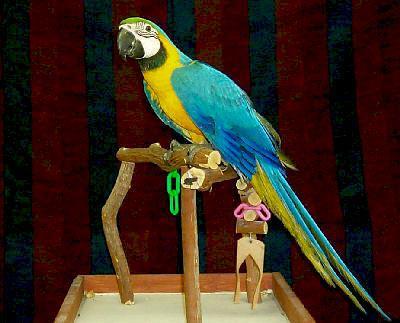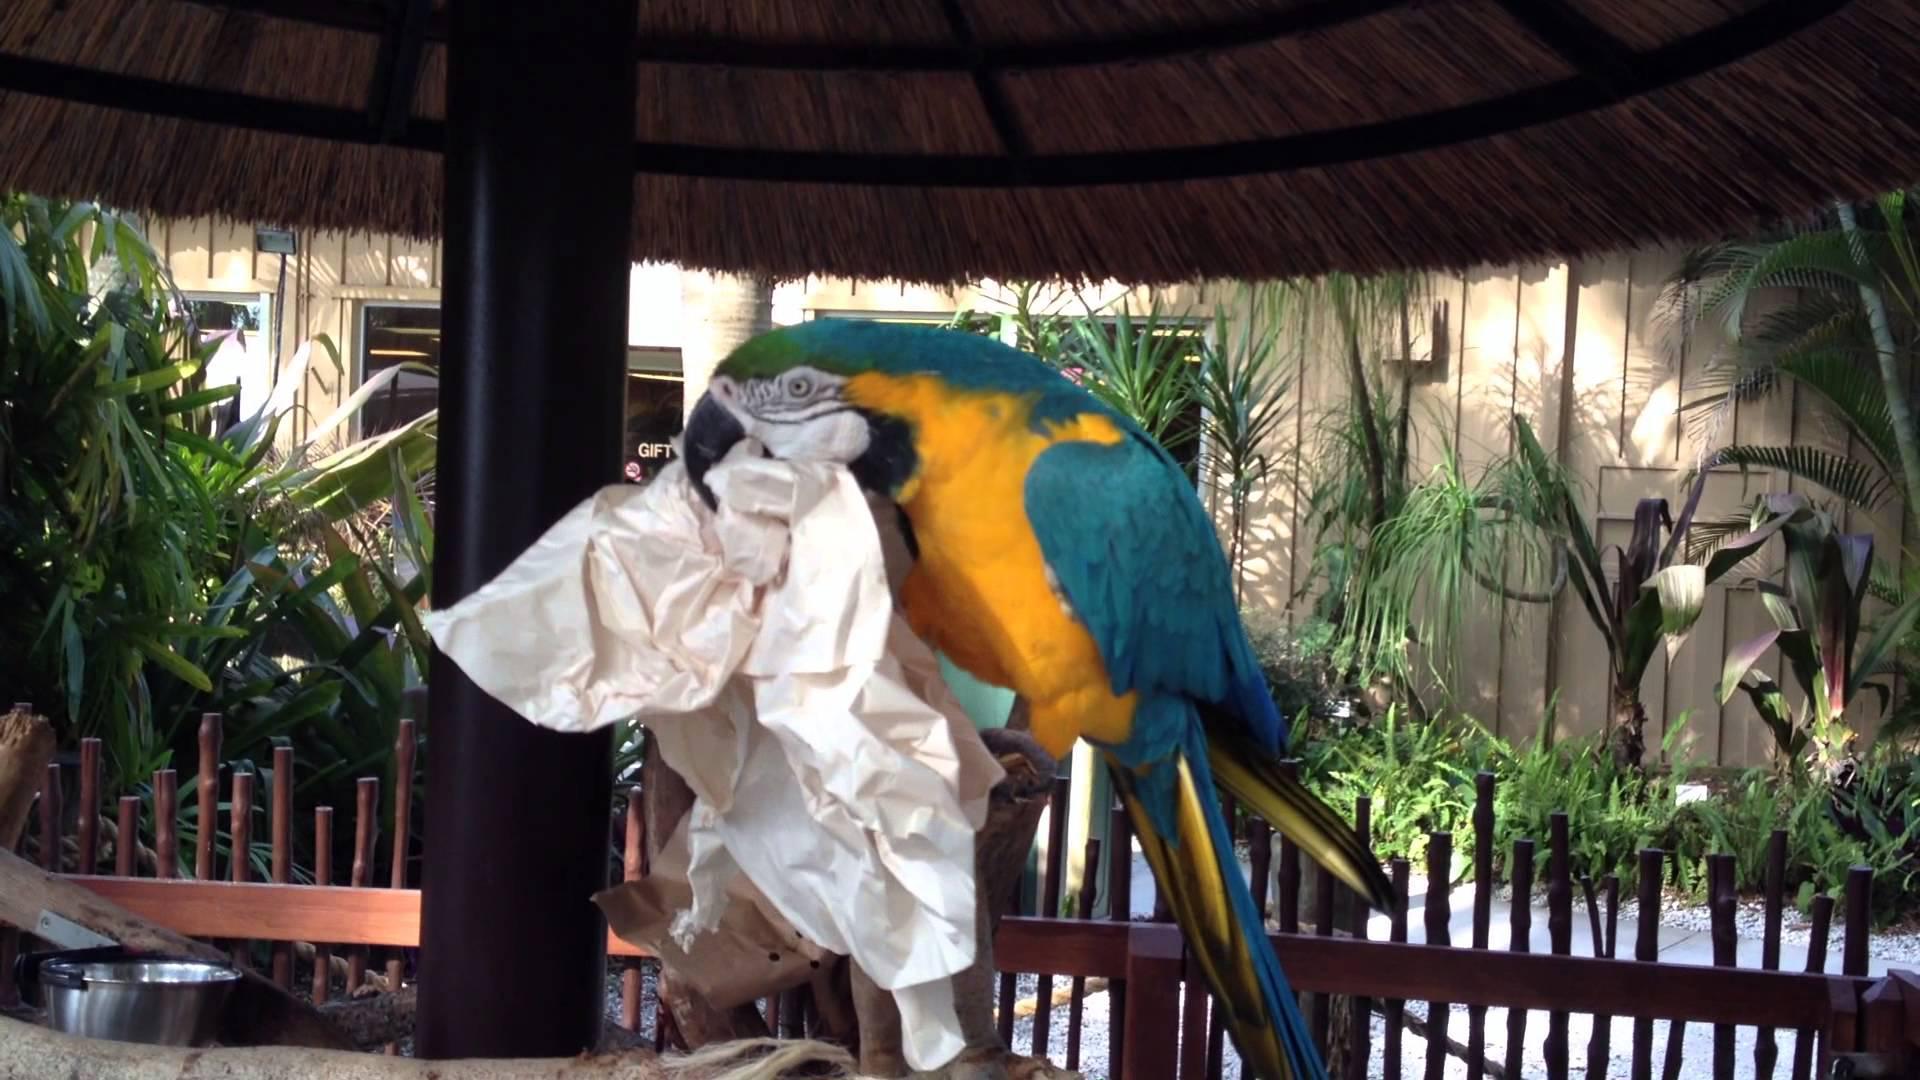The first image is the image on the left, the second image is the image on the right. For the images shown, is this caption "The macaws are all on their feet." true? Answer yes or no. Yes. 